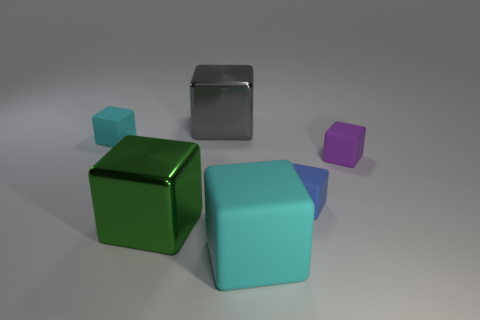Subtract all large gray cubes. How many cubes are left? 5 Subtract all purple cubes. How many cubes are left? 5 Subtract all blue blocks. Subtract all gray cylinders. How many blocks are left? 5 Add 1 purple rubber things. How many objects exist? 7 Subtract all blue metal things. Subtract all blue cubes. How many objects are left? 5 Add 6 tiny blue things. How many tiny blue things are left? 7 Add 5 cyan matte objects. How many cyan matte objects exist? 7 Subtract 1 cyan cubes. How many objects are left? 5 